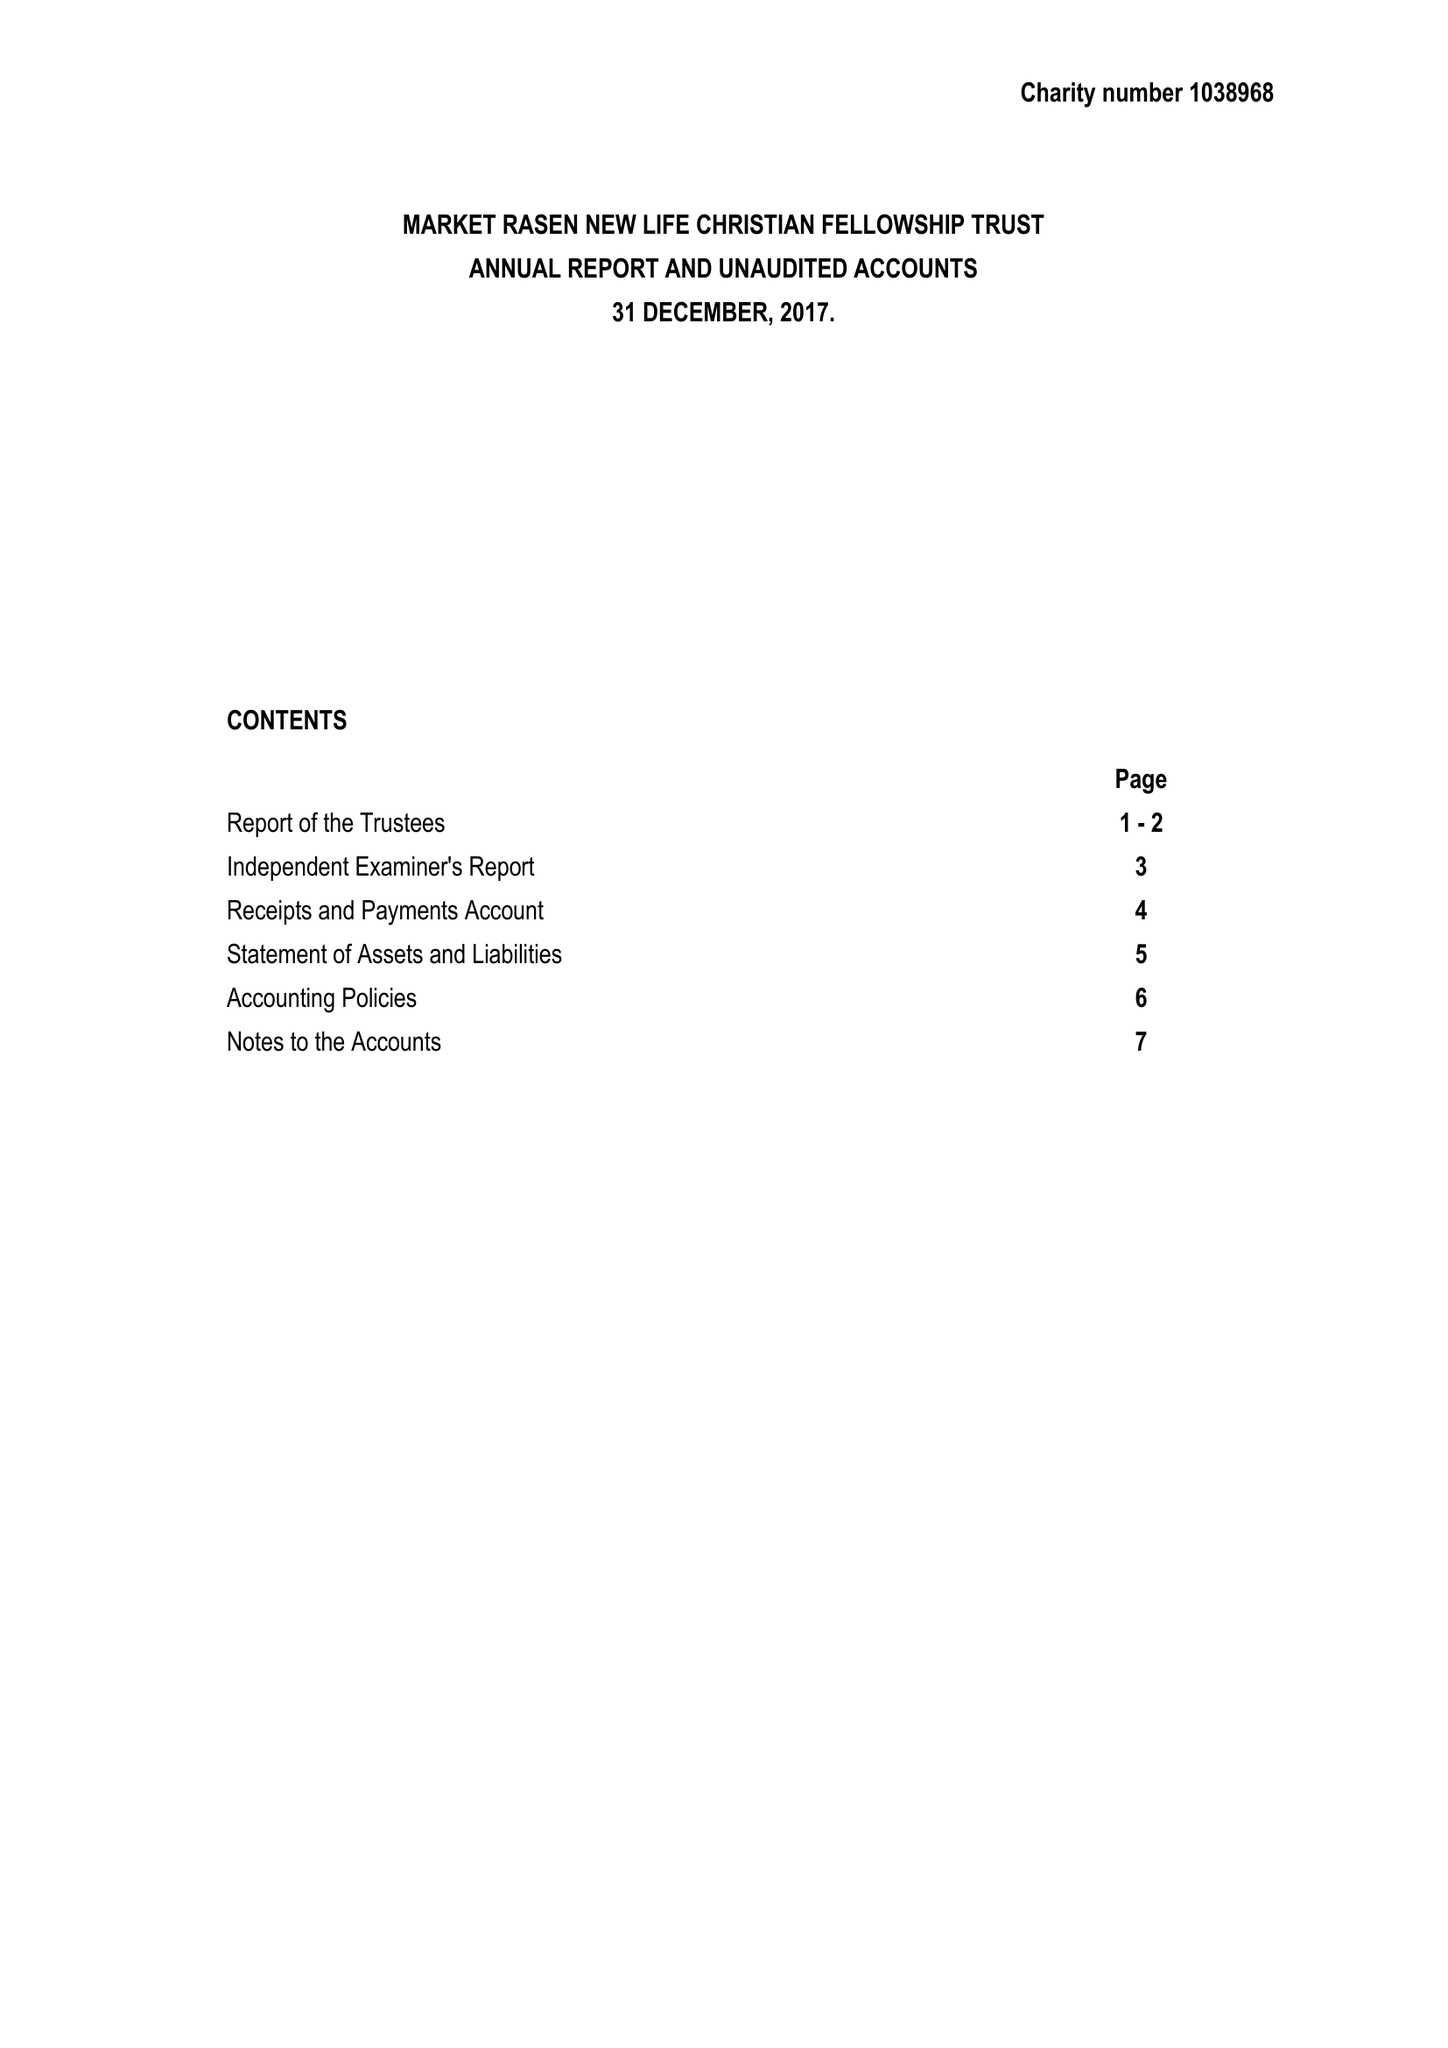What is the value for the address__postcode?
Answer the question using a single word or phrase. LN8 3AR 